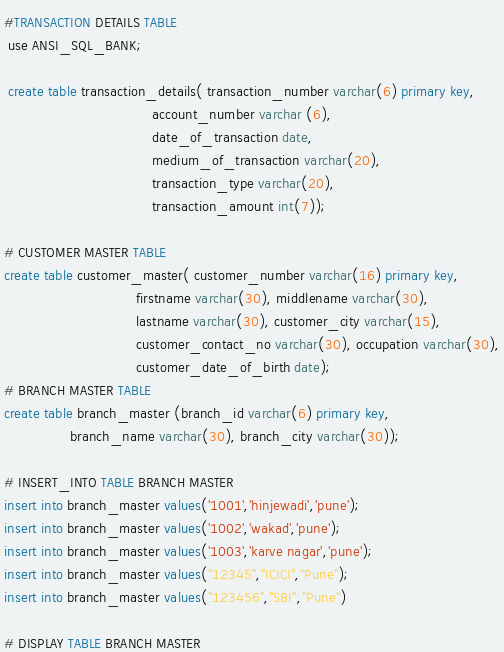<code> <loc_0><loc_0><loc_500><loc_500><_SQL_>
#TRANSACTION DETAILS TABLE
 use ANSI_SQL_BANK;
 
 create table transaction_details( transaction_number varchar(6) primary key, 
									account_number varchar (6),
                                    date_of_transaction date,
                                    medium_of_transaction varchar(20),
                                    transaction_type varchar(20),
                                    transaction_amount int(7));
                                    
# CUSTOMER MASTER TABLE
create table customer_master( customer_number varchar(16) primary key,
								firstname varchar(30), middlename varchar(30),
                                lastname varchar(30), customer_city varchar(15),
                                customer_contact_no varchar(30), occupation varchar(30),
                                customer_date_of_birth date);
# BRANCH MASTER TABLE
create table branch_master (branch_id varchar(6) primary key,
				branch_name varchar(30), branch_city varchar(30));
                
# INSERT_INTO TABLE BRANCH MASTER 
insert into branch_master values('1001','hinjewadi','pune');
insert into branch_master values('1002','wakad','pune');
insert into branch_master values('1003','karve nagar','pune');
insert into branch_master values("12345","ICICI","Pune");
insert into branch_master values("123456","SBI","Pune")

# DISPLAY TABLE BRANCH MASTER</code> 